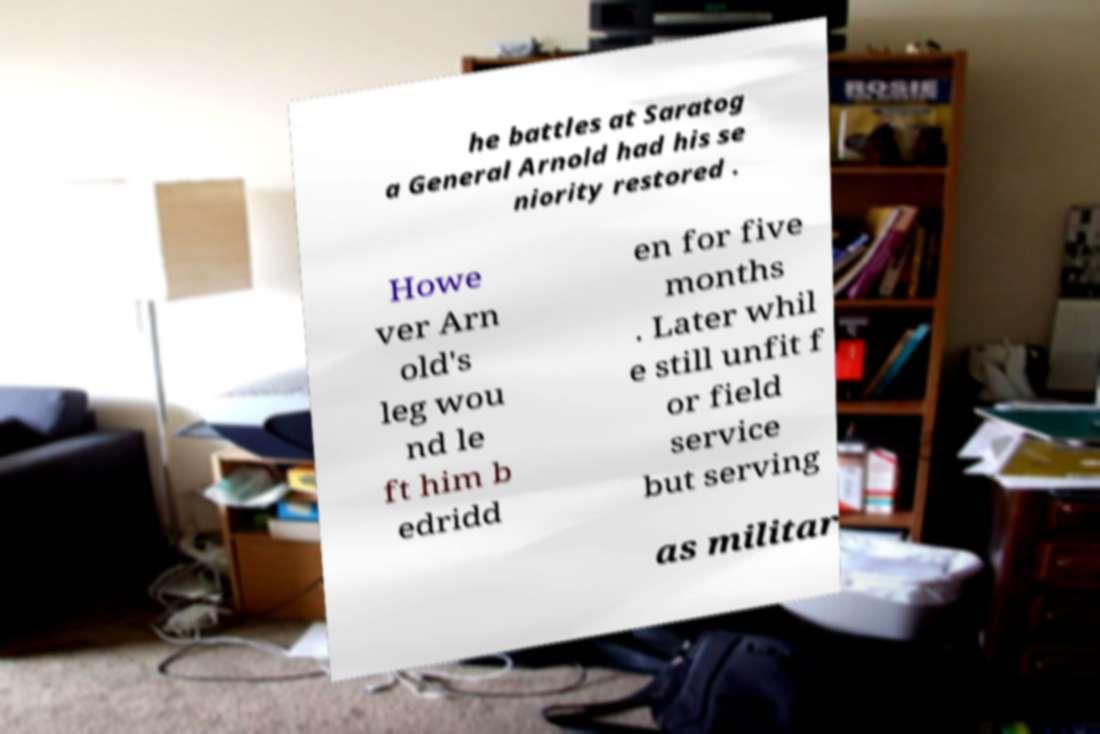Please read and relay the text visible in this image. What does it say? he battles at Saratog a General Arnold had his se niority restored . Howe ver Arn old's leg wou nd le ft him b edridd en for five months . Later whil e still unfit f or field service but serving as militar 